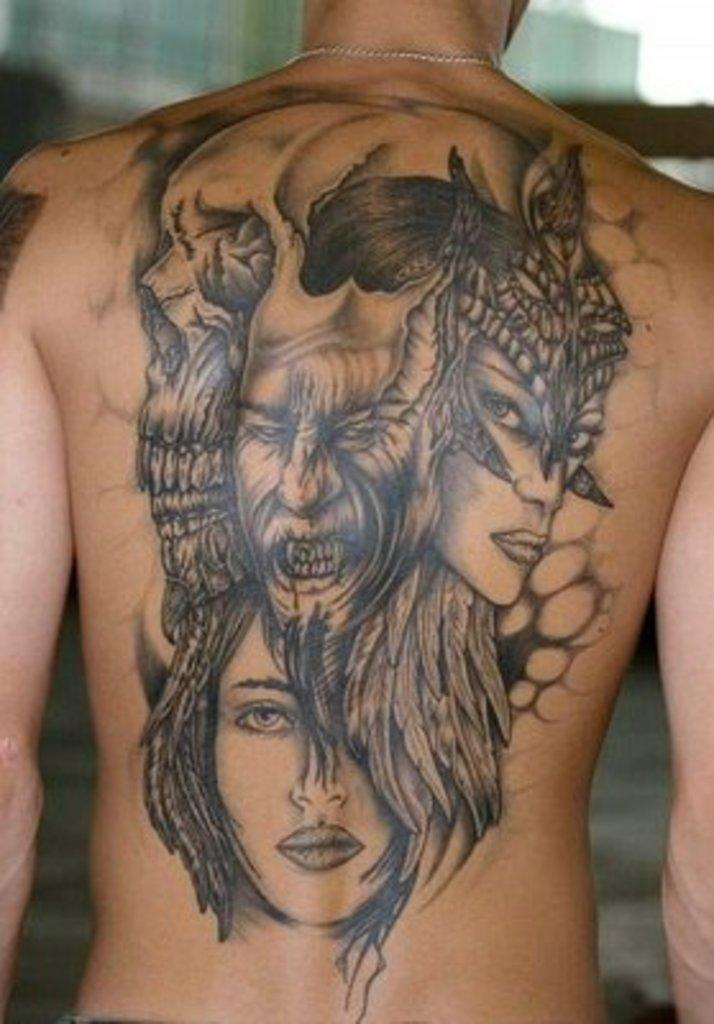What is visible on the person's back in the image? There is a tattoo on a person's back in the image. What type of flame can be seen on the person's leg in the image? There is no flame visible on the person's leg or any other part of their body in the image. 